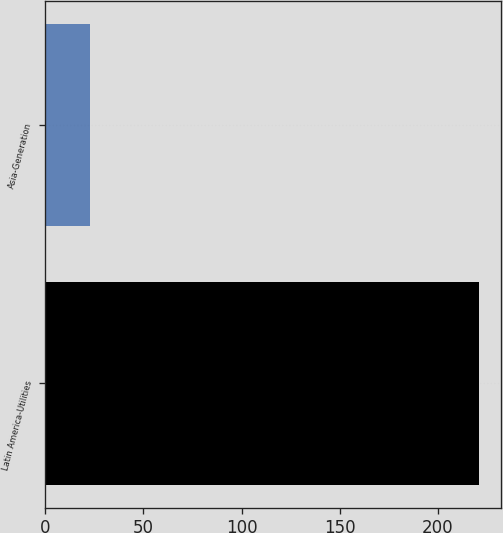Convert chart. <chart><loc_0><loc_0><loc_500><loc_500><bar_chart><fcel>Latin America-Utilities<fcel>Asia-Generation<nl><fcel>221<fcel>23<nl></chart> 